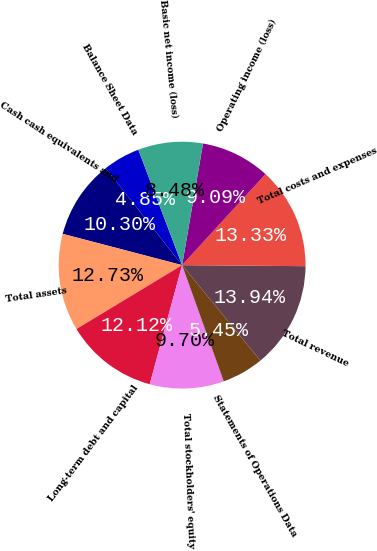Convert chart. <chart><loc_0><loc_0><loc_500><loc_500><pie_chart><fcel>Balance Sheet Data<fcel>Cash cash equivalents and<fcel>Total assets<fcel>Long-term debt and capital<fcel>Total stockholders' equity<fcel>Statements of Operations Data<fcel>Total revenue<fcel>Total costs and expenses<fcel>Operating income (loss)<fcel>Basic net income (loss)<nl><fcel>4.85%<fcel>10.3%<fcel>12.73%<fcel>12.12%<fcel>9.7%<fcel>5.45%<fcel>13.94%<fcel>13.33%<fcel>9.09%<fcel>8.48%<nl></chart> 